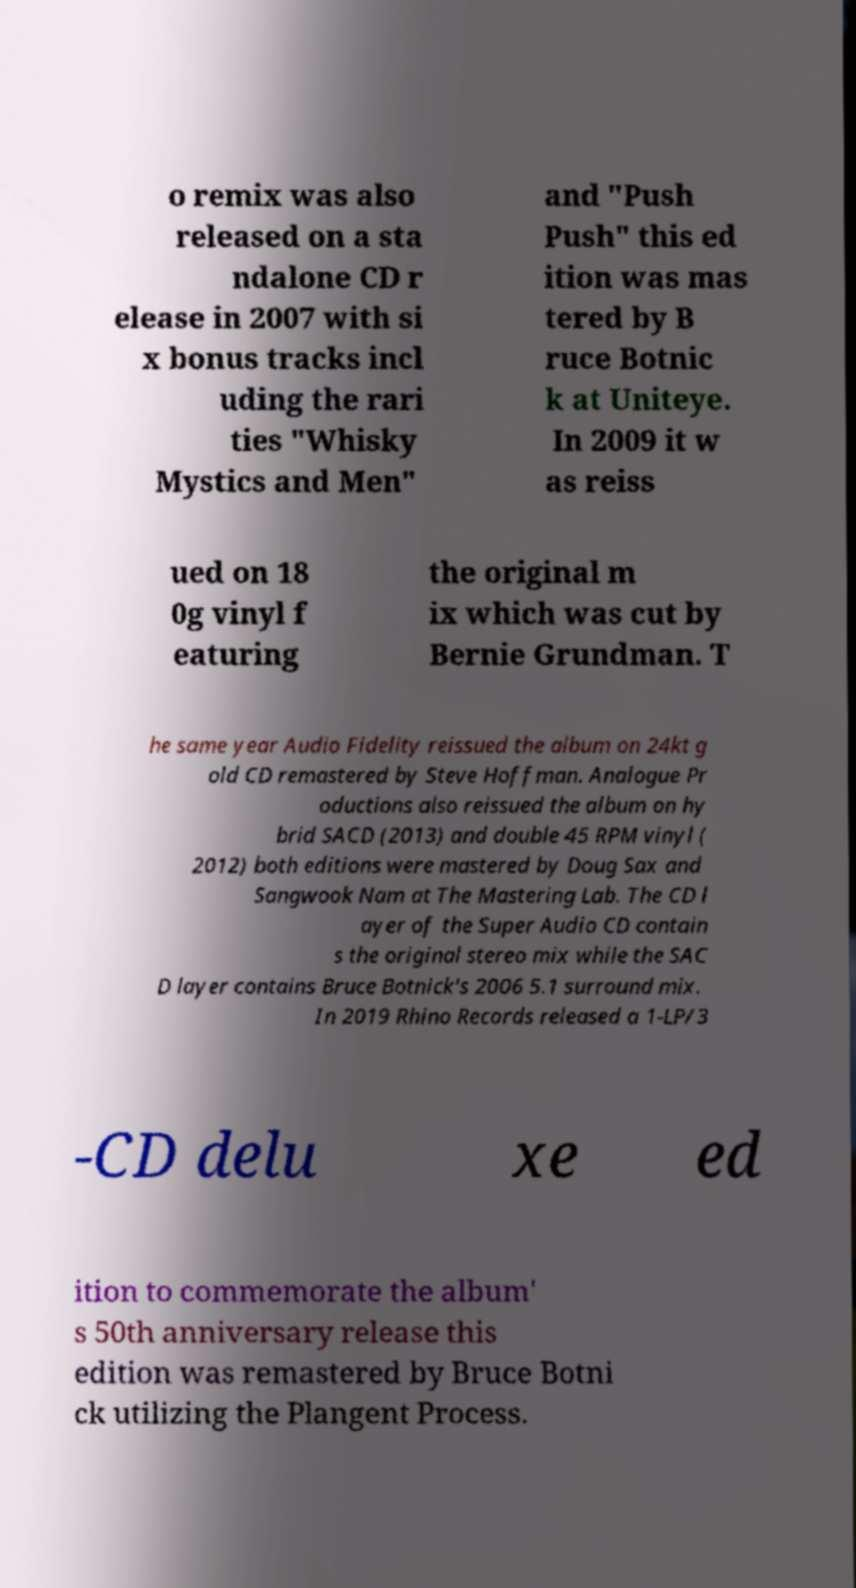There's text embedded in this image that I need extracted. Can you transcribe it verbatim? o remix was also released on a sta ndalone CD r elease in 2007 with si x bonus tracks incl uding the rari ties "Whisky Mystics and Men" and "Push Push" this ed ition was mas tered by B ruce Botnic k at Uniteye. In 2009 it w as reiss ued on 18 0g vinyl f eaturing the original m ix which was cut by Bernie Grundman. T he same year Audio Fidelity reissued the album on 24kt g old CD remastered by Steve Hoffman. Analogue Pr oductions also reissued the album on hy brid SACD (2013) and double 45 RPM vinyl ( 2012) both editions were mastered by Doug Sax and Sangwook Nam at The Mastering Lab. The CD l ayer of the Super Audio CD contain s the original stereo mix while the SAC D layer contains Bruce Botnick's 2006 5.1 surround mix. In 2019 Rhino Records released a 1-LP/3 -CD delu xe ed ition to commemorate the album' s 50th anniversary release this edition was remastered by Bruce Botni ck utilizing the Plangent Process. 